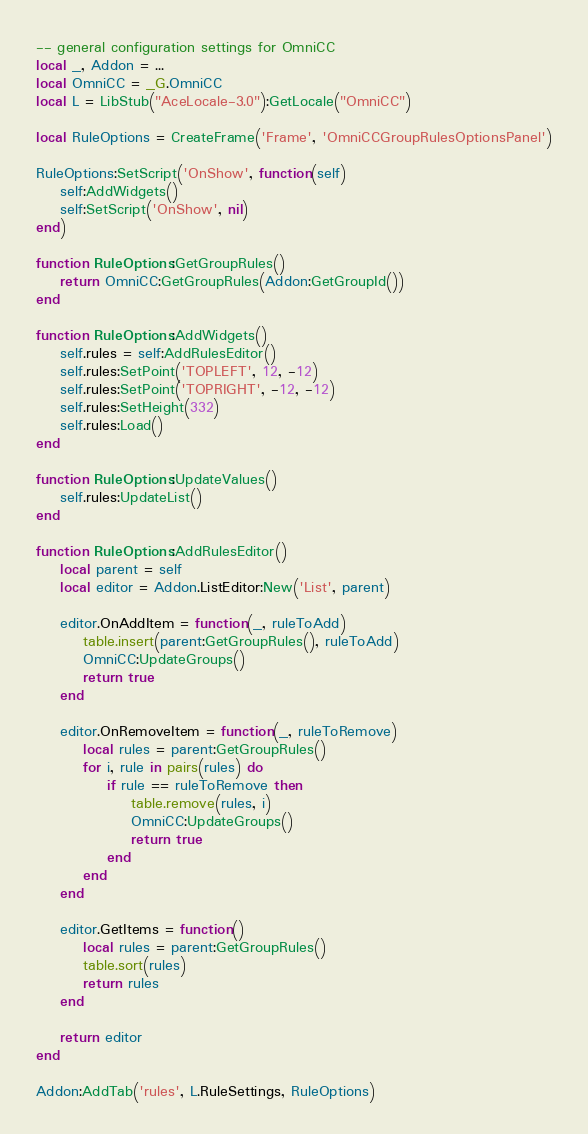<code> <loc_0><loc_0><loc_500><loc_500><_Lua_>-- general configuration settings for OmniCC
local _, Addon = ...
local OmniCC = _G.OmniCC
local L = LibStub("AceLocale-3.0"):GetLocale("OmniCC")

local RuleOptions = CreateFrame('Frame', 'OmniCCGroupRulesOptionsPanel')

RuleOptions:SetScript('OnShow', function(self)
	self:AddWidgets()
	self:SetScript('OnShow', nil)
end)

function RuleOptions:GetGroupRules()
	return OmniCC:GetGroupRules(Addon:GetGroupId())
end

function RuleOptions:AddWidgets()
	self.rules = self:AddRulesEditor()
	self.rules:SetPoint('TOPLEFT', 12, -12)
	self.rules:SetPoint('TOPRIGHT', -12, -12)
	self.rules:SetHeight(332)
	self.rules:Load()
end

function RuleOptions:UpdateValues()
	self.rules:UpdateList()
end

function RuleOptions:AddRulesEditor()
	local parent = self
	local editor = Addon.ListEditor:New('List', parent)

	editor.OnAddItem = function(_, ruleToAdd)
		table.insert(parent:GetGroupRules(), ruleToAdd)
		OmniCC:UpdateGroups()
		return true
	end

	editor.OnRemoveItem = function(_, ruleToRemove)
		local rules = parent:GetGroupRules()
		for i, rule in pairs(rules) do
			if rule == ruleToRemove then
				table.remove(rules, i)
				OmniCC:UpdateGroups()
				return true
			end
		end
	end

	editor.GetItems = function()
		local rules = parent:GetGroupRules()
		table.sort(rules)
		return rules
	end

	return editor
end

Addon:AddTab('rules', L.RuleSettings, RuleOptions)</code> 